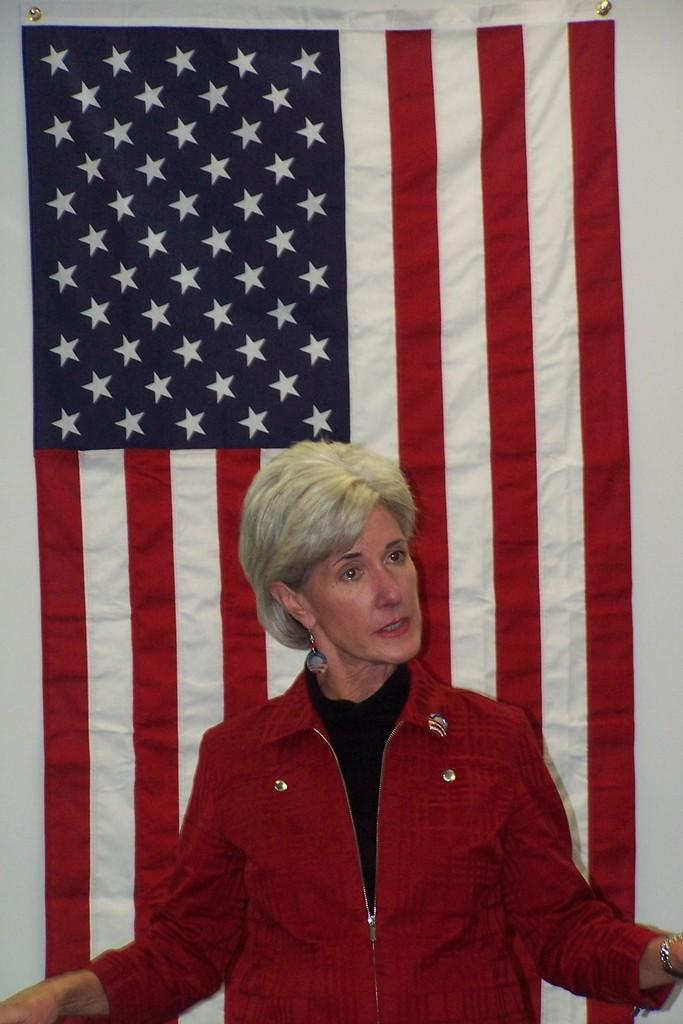Who is present in the image? There is a woman in the image. What is the woman wearing? The woman is wearing a red shirt. What can be seen on the wall behind the woman? There is a national flag on the wall behind the woman. What type of guide can be seen assisting the woman in the image? There is no guide present in the image; it only features a woman and a national flag on the wall. 